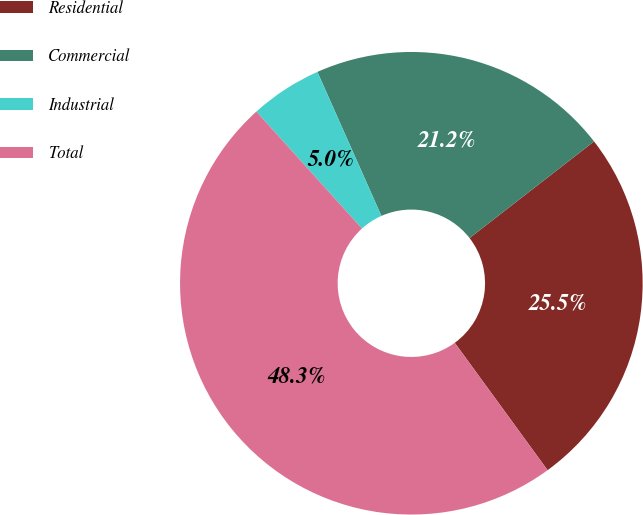Convert chart to OTSL. <chart><loc_0><loc_0><loc_500><loc_500><pie_chart><fcel>Residential<fcel>Commercial<fcel>Industrial<fcel>Total<nl><fcel>25.48%<fcel>21.15%<fcel>5.03%<fcel>48.33%<nl></chart> 